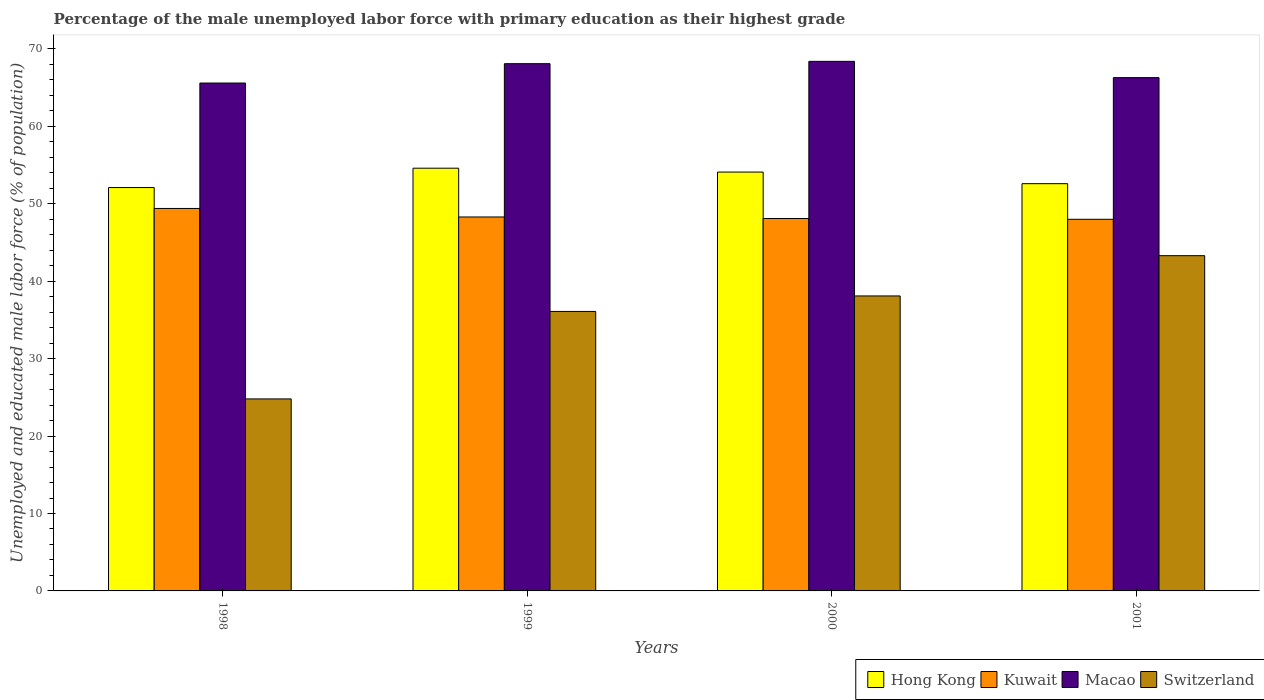How many different coloured bars are there?
Make the answer very short. 4. Are the number of bars per tick equal to the number of legend labels?
Offer a very short reply. Yes. Are the number of bars on each tick of the X-axis equal?
Give a very brief answer. Yes. How many bars are there on the 4th tick from the left?
Offer a very short reply. 4. How many bars are there on the 3rd tick from the right?
Ensure brevity in your answer.  4. What is the label of the 4th group of bars from the left?
Provide a short and direct response. 2001. What is the percentage of the unemployed male labor force with primary education in Switzerland in 2001?
Provide a succinct answer. 43.3. Across all years, what is the maximum percentage of the unemployed male labor force with primary education in Hong Kong?
Your answer should be compact. 54.6. Across all years, what is the minimum percentage of the unemployed male labor force with primary education in Macao?
Offer a very short reply. 65.6. In which year was the percentage of the unemployed male labor force with primary education in Hong Kong minimum?
Your answer should be very brief. 1998. What is the total percentage of the unemployed male labor force with primary education in Switzerland in the graph?
Your response must be concise. 142.3. What is the difference between the percentage of the unemployed male labor force with primary education in Hong Kong in 1998 and the percentage of the unemployed male labor force with primary education in Macao in 1999?
Offer a very short reply. -16. What is the average percentage of the unemployed male labor force with primary education in Hong Kong per year?
Provide a short and direct response. 53.35. In the year 1999, what is the difference between the percentage of the unemployed male labor force with primary education in Macao and percentage of the unemployed male labor force with primary education in Hong Kong?
Your answer should be compact. 13.5. What is the ratio of the percentage of the unemployed male labor force with primary education in Hong Kong in 2000 to that in 2001?
Your answer should be compact. 1.03. What is the difference between the highest and the second highest percentage of the unemployed male labor force with primary education in Macao?
Your answer should be compact. 0.3. What is the difference between the highest and the lowest percentage of the unemployed male labor force with primary education in Macao?
Provide a succinct answer. 2.8. Is the sum of the percentage of the unemployed male labor force with primary education in Macao in 1999 and 2000 greater than the maximum percentage of the unemployed male labor force with primary education in Kuwait across all years?
Offer a terse response. Yes. What does the 3rd bar from the left in 2000 represents?
Make the answer very short. Macao. What does the 2nd bar from the right in 1998 represents?
Provide a short and direct response. Macao. Is it the case that in every year, the sum of the percentage of the unemployed male labor force with primary education in Switzerland and percentage of the unemployed male labor force with primary education in Kuwait is greater than the percentage of the unemployed male labor force with primary education in Hong Kong?
Give a very brief answer. Yes. How many bars are there?
Ensure brevity in your answer.  16. Are all the bars in the graph horizontal?
Keep it short and to the point. No. What is the difference between two consecutive major ticks on the Y-axis?
Ensure brevity in your answer.  10. Are the values on the major ticks of Y-axis written in scientific E-notation?
Your answer should be compact. No. Where does the legend appear in the graph?
Offer a terse response. Bottom right. How many legend labels are there?
Your response must be concise. 4. What is the title of the graph?
Offer a terse response. Percentage of the male unemployed labor force with primary education as their highest grade. What is the label or title of the X-axis?
Ensure brevity in your answer.  Years. What is the label or title of the Y-axis?
Offer a very short reply. Unemployed and educated male labor force (% of population). What is the Unemployed and educated male labor force (% of population) of Hong Kong in 1998?
Ensure brevity in your answer.  52.1. What is the Unemployed and educated male labor force (% of population) of Kuwait in 1998?
Your response must be concise. 49.4. What is the Unemployed and educated male labor force (% of population) of Macao in 1998?
Make the answer very short. 65.6. What is the Unemployed and educated male labor force (% of population) of Switzerland in 1998?
Make the answer very short. 24.8. What is the Unemployed and educated male labor force (% of population) of Hong Kong in 1999?
Your response must be concise. 54.6. What is the Unemployed and educated male labor force (% of population) in Kuwait in 1999?
Make the answer very short. 48.3. What is the Unemployed and educated male labor force (% of population) of Macao in 1999?
Keep it short and to the point. 68.1. What is the Unemployed and educated male labor force (% of population) in Switzerland in 1999?
Offer a terse response. 36.1. What is the Unemployed and educated male labor force (% of population) in Hong Kong in 2000?
Offer a terse response. 54.1. What is the Unemployed and educated male labor force (% of population) in Kuwait in 2000?
Offer a very short reply. 48.1. What is the Unemployed and educated male labor force (% of population) in Macao in 2000?
Your answer should be very brief. 68.4. What is the Unemployed and educated male labor force (% of population) in Switzerland in 2000?
Keep it short and to the point. 38.1. What is the Unemployed and educated male labor force (% of population) of Hong Kong in 2001?
Provide a short and direct response. 52.6. What is the Unemployed and educated male labor force (% of population) of Macao in 2001?
Give a very brief answer. 66.3. What is the Unemployed and educated male labor force (% of population) in Switzerland in 2001?
Your response must be concise. 43.3. Across all years, what is the maximum Unemployed and educated male labor force (% of population) of Hong Kong?
Offer a terse response. 54.6. Across all years, what is the maximum Unemployed and educated male labor force (% of population) of Kuwait?
Offer a very short reply. 49.4. Across all years, what is the maximum Unemployed and educated male labor force (% of population) of Macao?
Provide a succinct answer. 68.4. Across all years, what is the maximum Unemployed and educated male labor force (% of population) in Switzerland?
Your response must be concise. 43.3. Across all years, what is the minimum Unemployed and educated male labor force (% of population) in Hong Kong?
Keep it short and to the point. 52.1. Across all years, what is the minimum Unemployed and educated male labor force (% of population) of Kuwait?
Offer a terse response. 48. Across all years, what is the minimum Unemployed and educated male labor force (% of population) of Macao?
Offer a terse response. 65.6. Across all years, what is the minimum Unemployed and educated male labor force (% of population) in Switzerland?
Provide a short and direct response. 24.8. What is the total Unemployed and educated male labor force (% of population) in Hong Kong in the graph?
Your response must be concise. 213.4. What is the total Unemployed and educated male labor force (% of population) of Kuwait in the graph?
Your answer should be very brief. 193.8. What is the total Unemployed and educated male labor force (% of population) in Macao in the graph?
Provide a succinct answer. 268.4. What is the total Unemployed and educated male labor force (% of population) of Switzerland in the graph?
Offer a terse response. 142.3. What is the difference between the Unemployed and educated male labor force (% of population) of Hong Kong in 1998 and that in 1999?
Provide a short and direct response. -2.5. What is the difference between the Unemployed and educated male labor force (% of population) in Kuwait in 1998 and that in 1999?
Make the answer very short. 1.1. What is the difference between the Unemployed and educated male labor force (% of population) of Macao in 1998 and that in 1999?
Keep it short and to the point. -2.5. What is the difference between the Unemployed and educated male labor force (% of population) of Kuwait in 1998 and that in 2000?
Your answer should be compact. 1.3. What is the difference between the Unemployed and educated male labor force (% of population) of Kuwait in 1998 and that in 2001?
Provide a short and direct response. 1.4. What is the difference between the Unemployed and educated male labor force (% of population) of Macao in 1998 and that in 2001?
Offer a terse response. -0.7. What is the difference between the Unemployed and educated male labor force (% of population) in Switzerland in 1998 and that in 2001?
Your response must be concise. -18.5. What is the difference between the Unemployed and educated male labor force (% of population) of Hong Kong in 1999 and that in 2000?
Ensure brevity in your answer.  0.5. What is the difference between the Unemployed and educated male labor force (% of population) of Kuwait in 1999 and that in 2000?
Your answer should be compact. 0.2. What is the difference between the Unemployed and educated male labor force (% of population) in Macao in 1999 and that in 2000?
Ensure brevity in your answer.  -0.3. What is the difference between the Unemployed and educated male labor force (% of population) in Macao in 1999 and that in 2001?
Make the answer very short. 1.8. What is the difference between the Unemployed and educated male labor force (% of population) in Switzerland in 1999 and that in 2001?
Your answer should be compact. -7.2. What is the difference between the Unemployed and educated male labor force (% of population) of Hong Kong in 2000 and that in 2001?
Offer a terse response. 1.5. What is the difference between the Unemployed and educated male labor force (% of population) of Macao in 2000 and that in 2001?
Provide a short and direct response. 2.1. What is the difference between the Unemployed and educated male labor force (% of population) of Switzerland in 2000 and that in 2001?
Provide a short and direct response. -5.2. What is the difference between the Unemployed and educated male labor force (% of population) in Hong Kong in 1998 and the Unemployed and educated male labor force (% of population) in Kuwait in 1999?
Provide a short and direct response. 3.8. What is the difference between the Unemployed and educated male labor force (% of population) in Hong Kong in 1998 and the Unemployed and educated male labor force (% of population) in Switzerland in 1999?
Make the answer very short. 16. What is the difference between the Unemployed and educated male labor force (% of population) of Kuwait in 1998 and the Unemployed and educated male labor force (% of population) of Macao in 1999?
Offer a terse response. -18.7. What is the difference between the Unemployed and educated male labor force (% of population) in Macao in 1998 and the Unemployed and educated male labor force (% of population) in Switzerland in 1999?
Keep it short and to the point. 29.5. What is the difference between the Unemployed and educated male labor force (% of population) in Hong Kong in 1998 and the Unemployed and educated male labor force (% of population) in Kuwait in 2000?
Your answer should be compact. 4. What is the difference between the Unemployed and educated male labor force (% of population) of Hong Kong in 1998 and the Unemployed and educated male labor force (% of population) of Macao in 2000?
Give a very brief answer. -16.3. What is the difference between the Unemployed and educated male labor force (% of population) in Kuwait in 1998 and the Unemployed and educated male labor force (% of population) in Macao in 2000?
Offer a very short reply. -19. What is the difference between the Unemployed and educated male labor force (% of population) of Hong Kong in 1998 and the Unemployed and educated male labor force (% of population) of Macao in 2001?
Keep it short and to the point. -14.2. What is the difference between the Unemployed and educated male labor force (% of population) in Hong Kong in 1998 and the Unemployed and educated male labor force (% of population) in Switzerland in 2001?
Provide a succinct answer. 8.8. What is the difference between the Unemployed and educated male labor force (% of population) of Kuwait in 1998 and the Unemployed and educated male labor force (% of population) of Macao in 2001?
Provide a short and direct response. -16.9. What is the difference between the Unemployed and educated male labor force (% of population) of Macao in 1998 and the Unemployed and educated male labor force (% of population) of Switzerland in 2001?
Offer a terse response. 22.3. What is the difference between the Unemployed and educated male labor force (% of population) in Hong Kong in 1999 and the Unemployed and educated male labor force (% of population) in Macao in 2000?
Provide a short and direct response. -13.8. What is the difference between the Unemployed and educated male labor force (% of population) of Kuwait in 1999 and the Unemployed and educated male labor force (% of population) of Macao in 2000?
Ensure brevity in your answer.  -20.1. What is the difference between the Unemployed and educated male labor force (% of population) of Kuwait in 1999 and the Unemployed and educated male labor force (% of population) of Switzerland in 2000?
Ensure brevity in your answer.  10.2. What is the difference between the Unemployed and educated male labor force (% of population) in Hong Kong in 1999 and the Unemployed and educated male labor force (% of population) in Macao in 2001?
Make the answer very short. -11.7. What is the difference between the Unemployed and educated male labor force (% of population) of Kuwait in 1999 and the Unemployed and educated male labor force (% of population) of Macao in 2001?
Keep it short and to the point. -18. What is the difference between the Unemployed and educated male labor force (% of population) of Macao in 1999 and the Unemployed and educated male labor force (% of population) of Switzerland in 2001?
Provide a succinct answer. 24.8. What is the difference between the Unemployed and educated male labor force (% of population) in Hong Kong in 2000 and the Unemployed and educated male labor force (% of population) in Kuwait in 2001?
Your answer should be compact. 6.1. What is the difference between the Unemployed and educated male labor force (% of population) of Hong Kong in 2000 and the Unemployed and educated male labor force (% of population) of Switzerland in 2001?
Offer a terse response. 10.8. What is the difference between the Unemployed and educated male labor force (% of population) in Kuwait in 2000 and the Unemployed and educated male labor force (% of population) in Macao in 2001?
Provide a short and direct response. -18.2. What is the difference between the Unemployed and educated male labor force (% of population) in Macao in 2000 and the Unemployed and educated male labor force (% of population) in Switzerland in 2001?
Make the answer very short. 25.1. What is the average Unemployed and educated male labor force (% of population) of Hong Kong per year?
Provide a succinct answer. 53.35. What is the average Unemployed and educated male labor force (% of population) in Kuwait per year?
Provide a short and direct response. 48.45. What is the average Unemployed and educated male labor force (% of population) of Macao per year?
Give a very brief answer. 67.1. What is the average Unemployed and educated male labor force (% of population) in Switzerland per year?
Make the answer very short. 35.58. In the year 1998, what is the difference between the Unemployed and educated male labor force (% of population) in Hong Kong and Unemployed and educated male labor force (% of population) in Macao?
Offer a very short reply. -13.5. In the year 1998, what is the difference between the Unemployed and educated male labor force (% of population) of Hong Kong and Unemployed and educated male labor force (% of population) of Switzerland?
Your answer should be very brief. 27.3. In the year 1998, what is the difference between the Unemployed and educated male labor force (% of population) of Kuwait and Unemployed and educated male labor force (% of population) of Macao?
Keep it short and to the point. -16.2. In the year 1998, what is the difference between the Unemployed and educated male labor force (% of population) of Kuwait and Unemployed and educated male labor force (% of population) of Switzerland?
Your response must be concise. 24.6. In the year 1998, what is the difference between the Unemployed and educated male labor force (% of population) in Macao and Unemployed and educated male labor force (% of population) in Switzerland?
Your response must be concise. 40.8. In the year 1999, what is the difference between the Unemployed and educated male labor force (% of population) of Hong Kong and Unemployed and educated male labor force (% of population) of Kuwait?
Provide a succinct answer. 6.3. In the year 1999, what is the difference between the Unemployed and educated male labor force (% of population) of Hong Kong and Unemployed and educated male labor force (% of population) of Macao?
Your answer should be compact. -13.5. In the year 1999, what is the difference between the Unemployed and educated male labor force (% of population) in Hong Kong and Unemployed and educated male labor force (% of population) in Switzerland?
Your response must be concise. 18.5. In the year 1999, what is the difference between the Unemployed and educated male labor force (% of population) in Kuwait and Unemployed and educated male labor force (% of population) in Macao?
Offer a terse response. -19.8. In the year 1999, what is the difference between the Unemployed and educated male labor force (% of population) in Kuwait and Unemployed and educated male labor force (% of population) in Switzerland?
Provide a short and direct response. 12.2. In the year 2000, what is the difference between the Unemployed and educated male labor force (% of population) in Hong Kong and Unemployed and educated male labor force (% of population) in Macao?
Provide a short and direct response. -14.3. In the year 2000, what is the difference between the Unemployed and educated male labor force (% of population) of Hong Kong and Unemployed and educated male labor force (% of population) of Switzerland?
Your answer should be very brief. 16. In the year 2000, what is the difference between the Unemployed and educated male labor force (% of population) of Kuwait and Unemployed and educated male labor force (% of population) of Macao?
Your answer should be compact. -20.3. In the year 2000, what is the difference between the Unemployed and educated male labor force (% of population) of Macao and Unemployed and educated male labor force (% of population) of Switzerland?
Your answer should be very brief. 30.3. In the year 2001, what is the difference between the Unemployed and educated male labor force (% of population) of Hong Kong and Unemployed and educated male labor force (% of population) of Kuwait?
Offer a terse response. 4.6. In the year 2001, what is the difference between the Unemployed and educated male labor force (% of population) of Hong Kong and Unemployed and educated male labor force (% of population) of Macao?
Provide a succinct answer. -13.7. In the year 2001, what is the difference between the Unemployed and educated male labor force (% of population) in Kuwait and Unemployed and educated male labor force (% of population) in Macao?
Provide a short and direct response. -18.3. In the year 2001, what is the difference between the Unemployed and educated male labor force (% of population) of Kuwait and Unemployed and educated male labor force (% of population) of Switzerland?
Your answer should be very brief. 4.7. In the year 2001, what is the difference between the Unemployed and educated male labor force (% of population) in Macao and Unemployed and educated male labor force (% of population) in Switzerland?
Make the answer very short. 23. What is the ratio of the Unemployed and educated male labor force (% of population) in Hong Kong in 1998 to that in 1999?
Offer a very short reply. 0.95. What is the ratio of the Unemployed and educated male labor force (% of population) in Kuwait in 1998 to that in 1999?
Your response must be concise. 1.02. What is the ratio of the Unemployed and educated male labor force (% of population) in Macao in 1998 to that in 1999?
Make the answer very short. 0.96. What is the ratio of the Unemployed and educated male labor force (% of population) of Switzerland in 1998 to that in 1999?
Provide a short and direct response. 0.69. What is the ratio of the Unemployed and educated male labor force (% of population) in Kuwait in 1998 to that in 2000?
Offer a terse response. 1.03. What is the ratio of the Unemployed and educated male labor force (% of population) in Macao in 1998 to that in 2000?
Your answer should be compact. 0.96. What is the ratio of the Unemployed and educated male labor force (% of population) of Switzerland in 1998 to that in 2000?
Your response must be concise. 0.65. What is the ratio of the Unemployed and educated male labor force (% of population) of Hong Kong in 1998 to that in 2001?
Keep it short and to the point. 0.99. What is the ratio of the Unemployed and educated male labor force (% of population) of Kuwait in 1998 to that in 2001?
Ensure brevity in your answer.  1.03. What is the ratio of the Unemployed and educated male labor force (% of population) in Switzerland in 1998 to that in 2001?
Your answer should be compact. 0.57. What is the ratio of the Unemployed and educated male labor force (% of population) in Hong Kong in 1999 to that in 2000?
Give a very brief answer. 1.01. What is the ratio of the Unemployed and educated male labor force (% of population) of Macao in 1999 to that in 2000?
Provide a succinct answer. 1. What is the ratio of the Unemployed and educated male labor force (% of population) of Switzerland in 1999 to that in 2000?
Your response must be concise. 0.95. What is the ratio of the Unemployed and educated male labor force (% of population) in Hong Kong in 1999 to that in 2001?
Offer a terse response. 1.04. What is the ratio of the Unemployed and educated male labor force (% of population) in Macao in 1999 to that in 2001?
Provide a short and direct response. 1.03. What is the ratio of the Unemployed and educated male labor force (% of population) of Switzerland in 1999 to that in 2001?
Provide a short and direct response. 0.83. What is the ratio of the Unemployed and educated male labor force (% of population) of Hong Kong in 2000 to that in 2001?
Ensure brevity in your answer.  1.03. What is the ratio of the Unemployed and educated male labor force (% of population) of Kuwait in 2000 to that in 2001?
Give a very brief answer. 1. What is the ratio of the Unemployed and educated male labor force (% of population) in Macao in 2000 to that in 2001?
Your answer should be compact. 1.03. What is the ratio of the Unemployed and educated male labor force (% of population) in Switzerland in 2000 to that in 2001?
Give a very brief answer. 0.88. What is the difference between the highest and the lowest Unemployed and educated male labor force (% of population) of Macao?
Offer a terse response. 2.8. What is the difference between the highest and the lowest Unemployed and educated male labor force (% of population) in Switzerland?
Give a very brief answer. 18.5. 